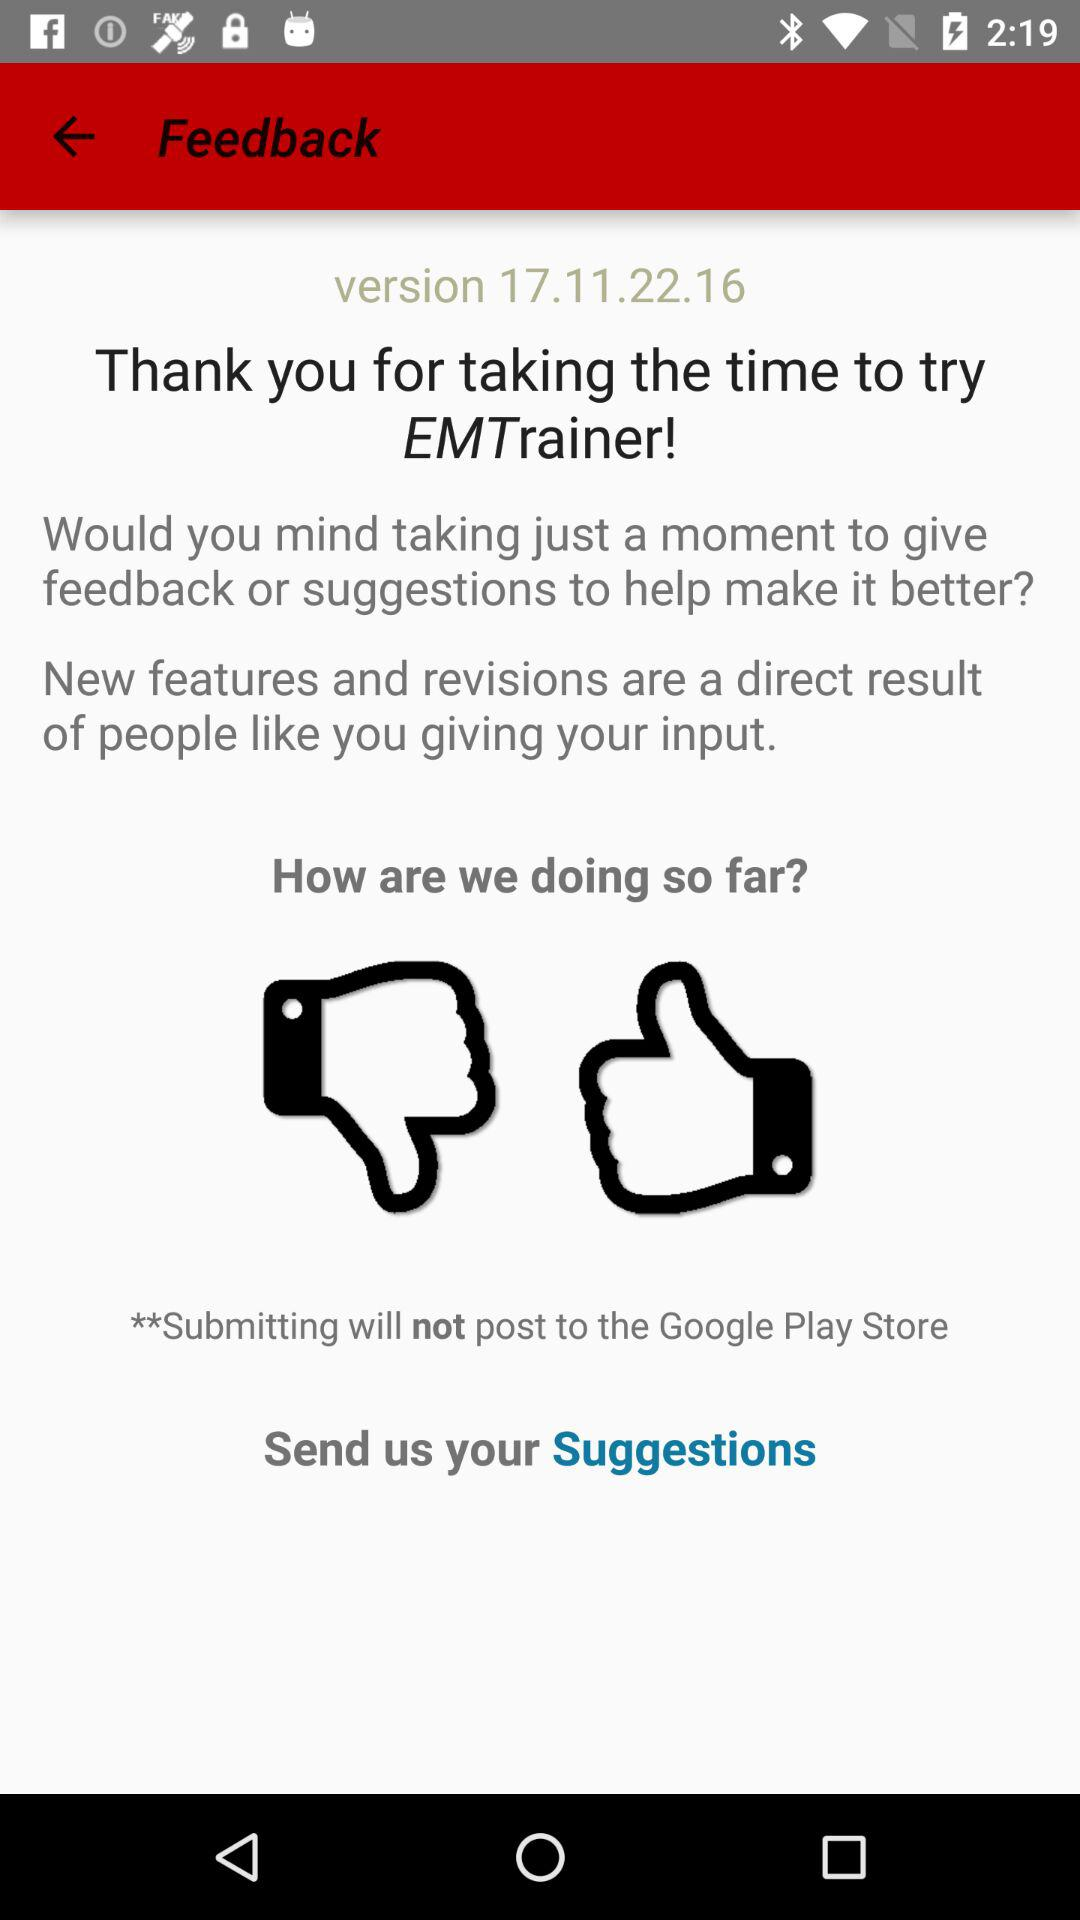What is the name of the application? The name of the application is "EMTrainer". 